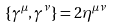Convert formula to latex. <formula><loc_0><loc_0><loc_500><loc_500>\{ \gamma ^ { \mu } , \gamma ^ { \nu } \} = 2 \eta ^ { \mu \nu }</formula> 